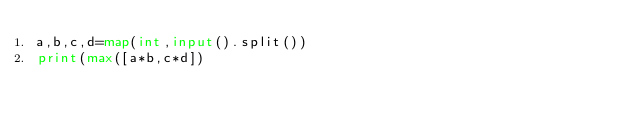Convert code to text. <code><loc_0><loc_0><loc_500><loc_500><_Python_>a,b,c,d=map(int,input().split())
print(max([a*b,c*d])</code> 